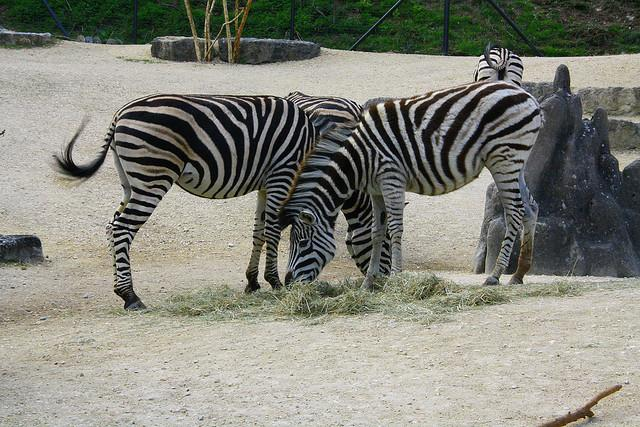What is fully visible on the animal on the left? tail 